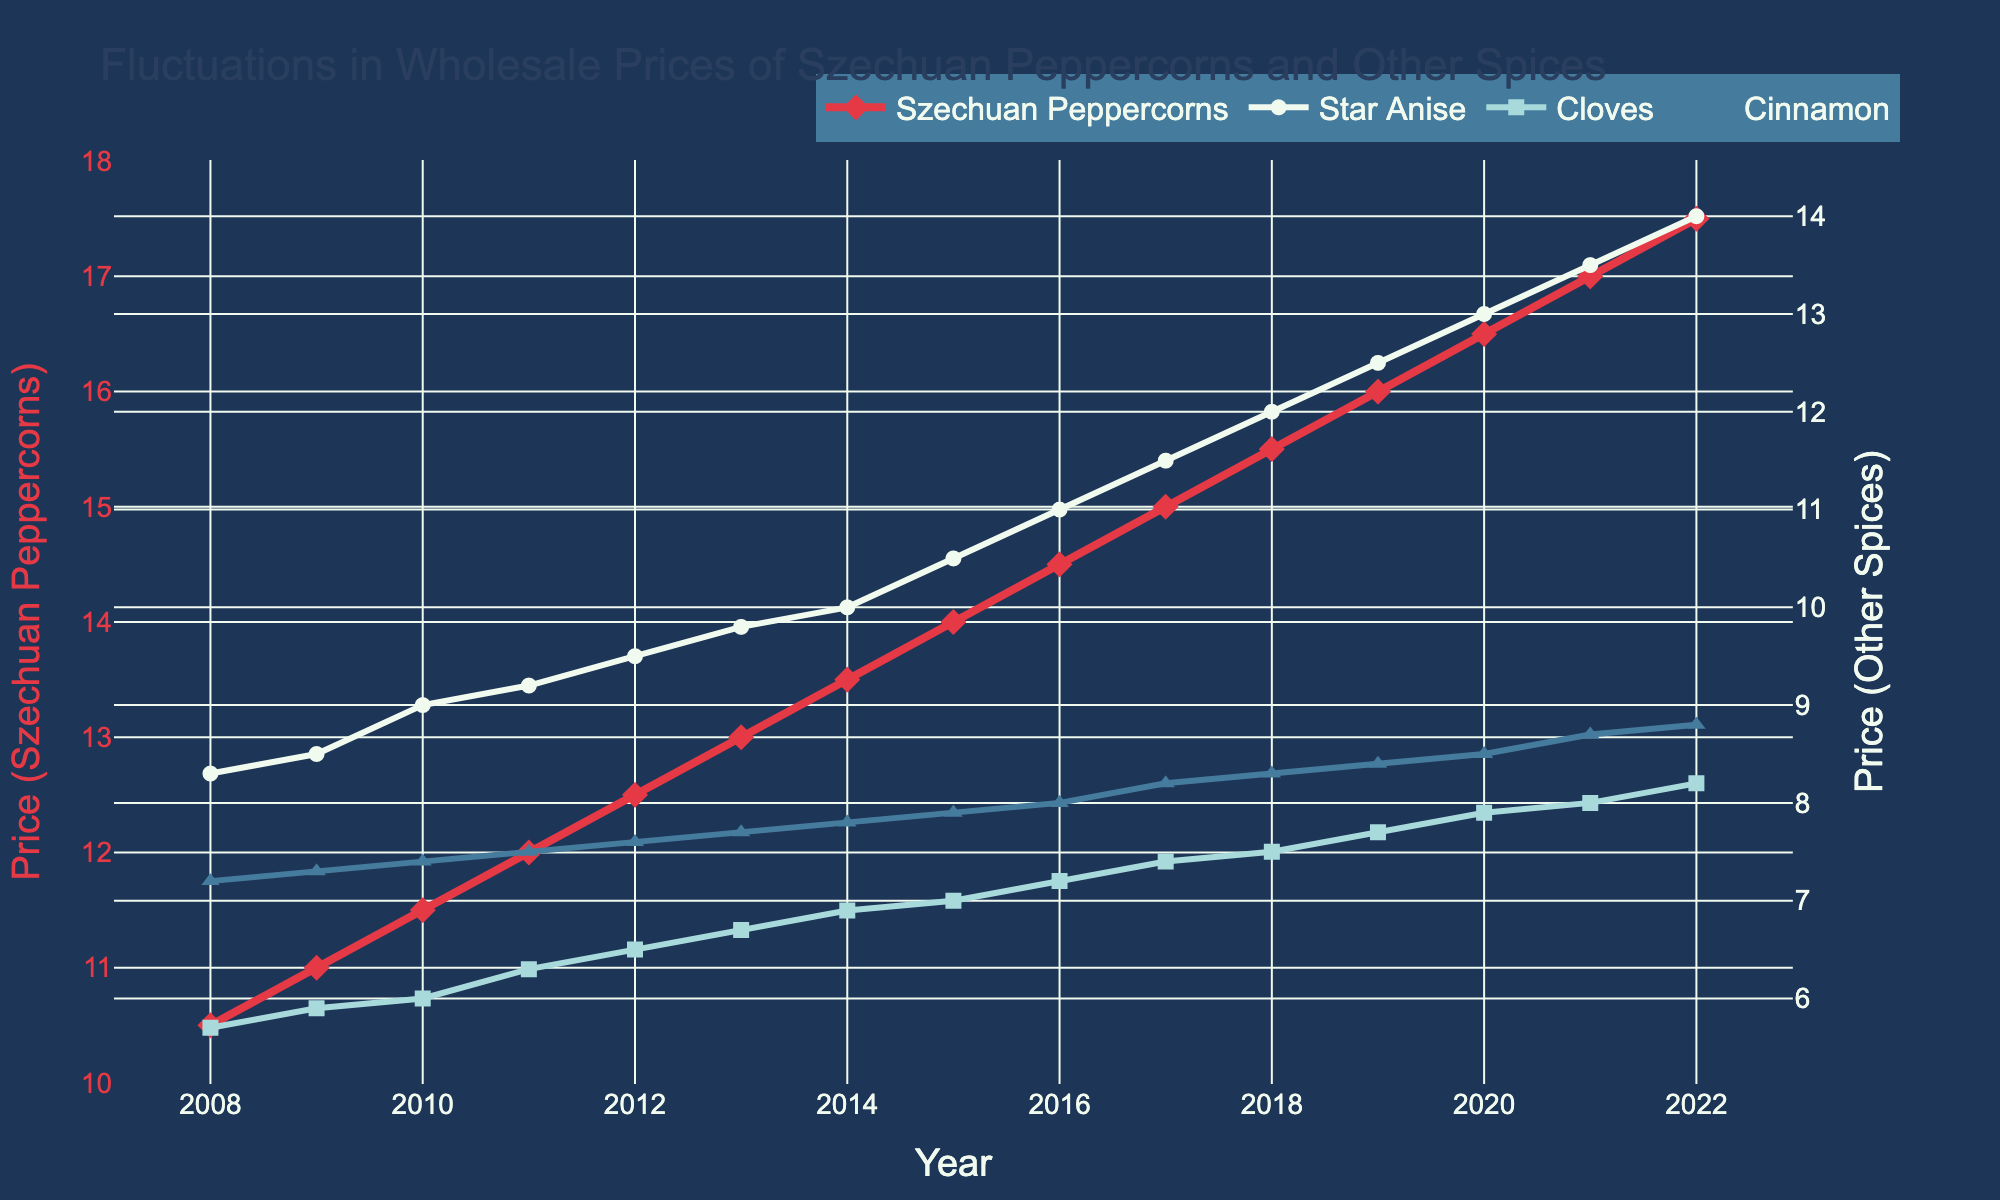What is the title of the plot? The title is displayed at the top of the figure. It indicates the subject of the plot.
Answer: Fluctuations in Wholesale Prices of Szechuan Peppercorns and Other Spices Which spice shows the highest price in the last year of the data? In 2022, check the last data points for each spice. The highest value corresponds to the spice reaching the highest price.
Answer: Szechuan Peppercorns How does the price of Szechuan Peppercorns in 2012 compare to 2008? Look at the plot points for Szechuan Peppercorns at 2012 and 2008 and compare the y-values.
Answer: Higher in 2012 What is the color used for the line representing Star Anise price fluctuations? The color distinguishes different spices. Refer to the legend identifying the color for Star Anise.
Answer: White Between which years was the sharpest increase in the price of Cloves observed? Follow the Cloves series and identify the steepest upward slope.
Answer: 2019 to 2020 Were the prices of Cinnamon and Star Anise ever equal? Compare the y-values across all years to see if they intersect or any overlapping points.
Answer: No Which year saw the price of Cinnamon surpass 8.0 for the first time? Trace the Cinnamon y-values and find when it crossed the threshold of 8.0.
Answer: 2017 What was the trend in the price of Star Anise from 2008 to 2022? Follow the Star Anise series and identify the overall direction of the slopes.
Answer: Increasing What is the average price of Szechuan Peppercorns over the 15-year period? Sum the prices of Szechuan Peppercorns for all years and divide by the number of years (15).
Answer: 14 By how much did the price of Szechuan Peppercorns increase from 2008 to 2022? Subtract the price in 2008 from the price in 2022 for Szechuan Peppercorns.
Answer: 7 